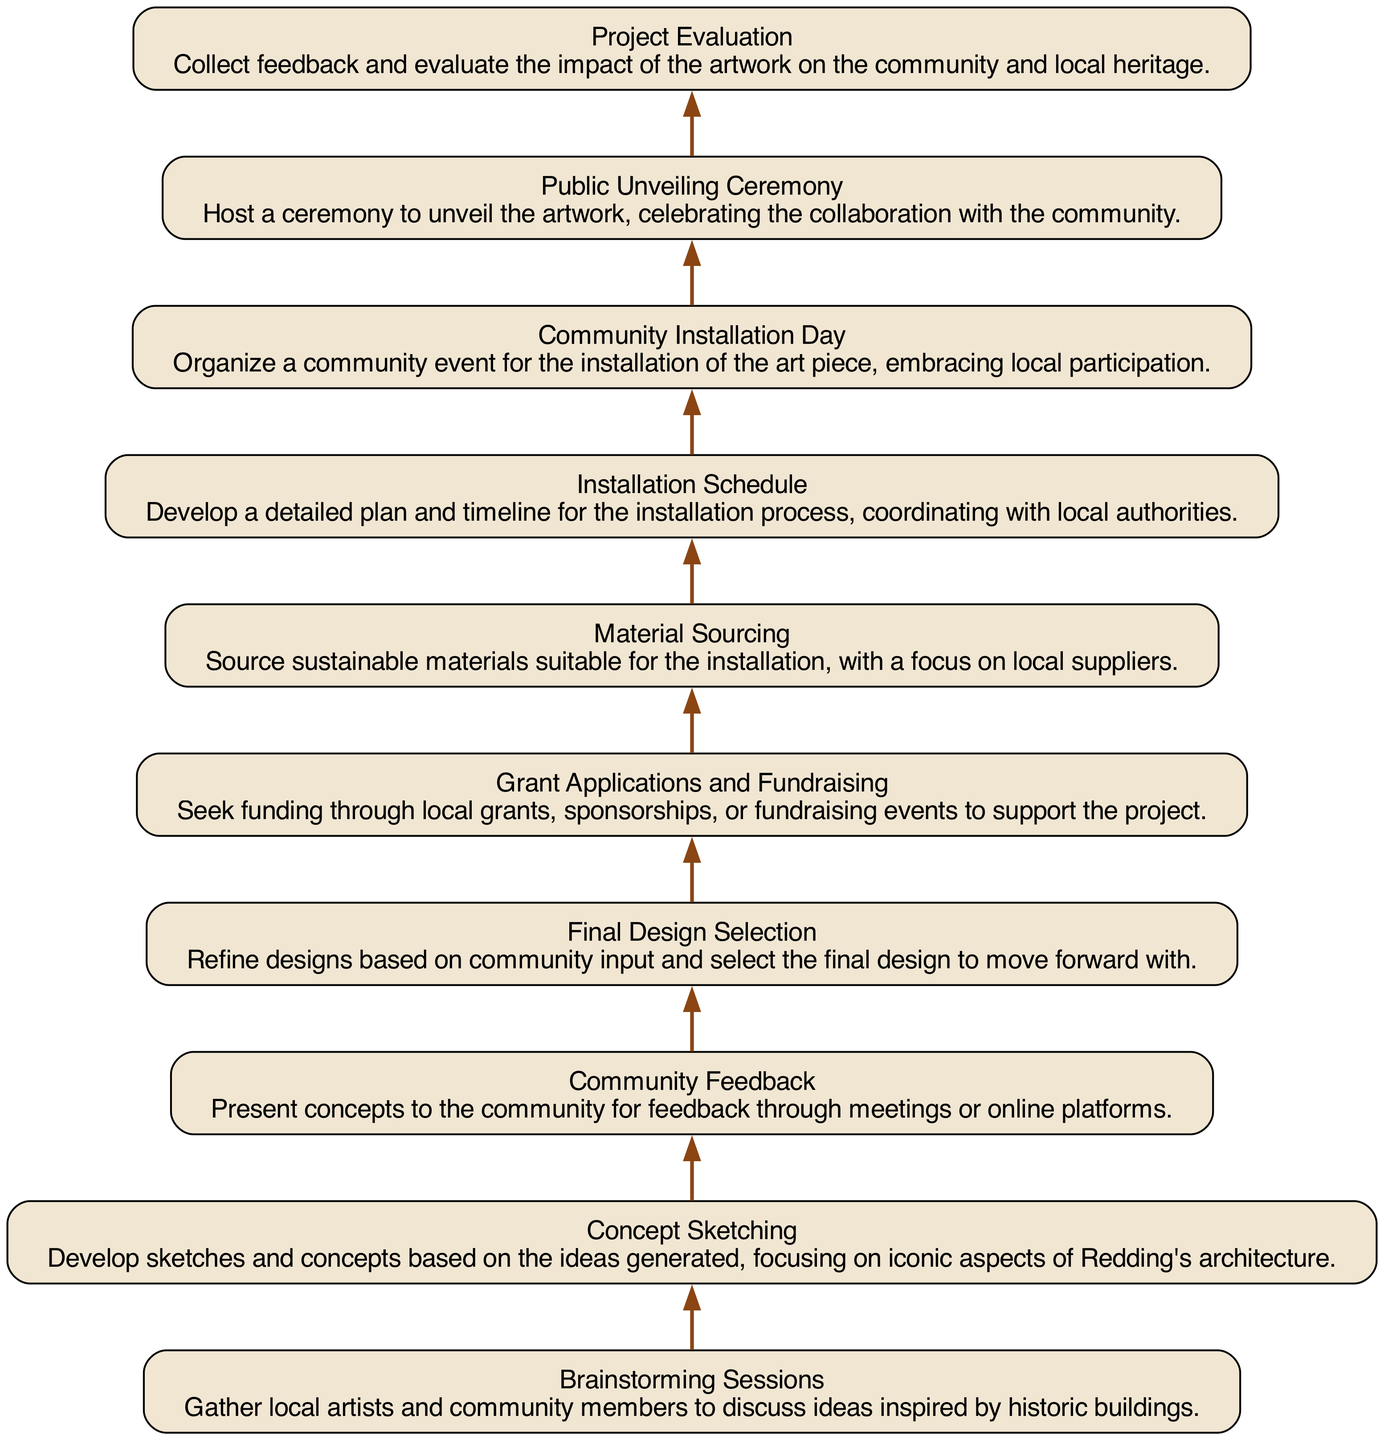What is the first step in the workflow? The diagram indicates that the first step is "Brainstorming Sessions," which is the initial node in the flow, relating to the idea generation phase.
Answer: Brainstorming Sessions How many nodes are there in the diagram? By counting the different elements that represent the various steps in the workflow, we find a total of 10 distinct nodes that describe each phase of the project.
Answer: 10 Which step comes after the "Final Design Selection"? The diagram shows that "Grant Applications and Fundraising" follows the "Final Design Selection," indicating the sequence of steps taken for project funding.
Answer: Grant Applications and Fundraising What type of event is organized to unveil the artwork? The diagram specifies that the event organized for unveiling the artwork is a "Public Unveiling Ceremony," marking a communal celebration of the completed project.
Answer: Public Unveiling Ceremony What step focuses on community participation during the installation? The "Community Installation Day" is highlighted as the step that emphasizes local involvement and participation in the installation of the art piece.
Answer: Community Installation Day What is the last step in the project workflow? The last node in the flowchart is "Project Evaluation," which indicates that after the installation, the project will be assessed for feedback and impact on the community.
Answer: Project Evaluation What is the main focus of the "Material Sourcing" step? "Material Sourcing" concentrates on the selection of sustainable materials from local suppliers, emphasizing an eco-friendly approach for the project.
Answer: Sustainable materials What comes before "Installation Schedule"? In the flow of the diagram, "Material Sourcing" precedes "Installation Schedule," indicating that sourcing materials is essential before planning the installation.
Answer: Material Sourcing How does community input influence the "Final Design Selection"? "Community Feedback" is a crucial step before the "Final Design Selection," meaning that input from the community helps refine and decide the final design to proceed with.
Answer: Community Feedback 